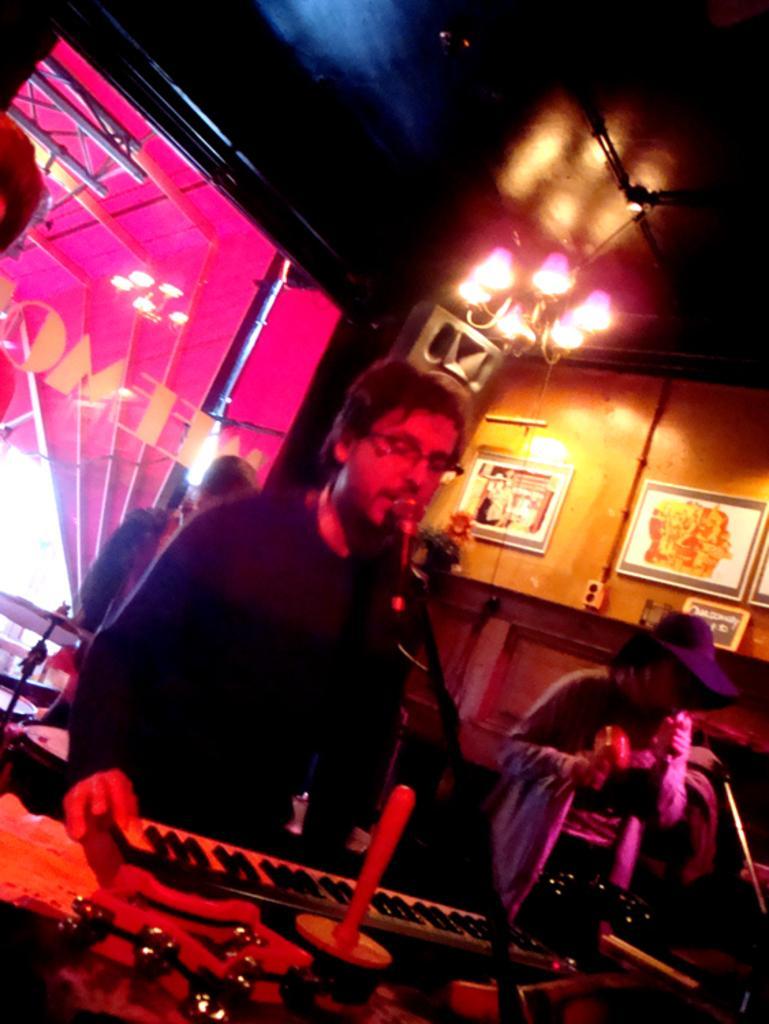Could you give a brief overview of what you see in this image? In this image there is a person playing a musical instrument, in front of him there is a mic, beside him there is a lady standing and holding a mike in her hand, behind them there is another person playing a musical instrument. In the background there is a glass window. At the top there is a ceiling and on the other side there are photo frames are hanging on the wall. 